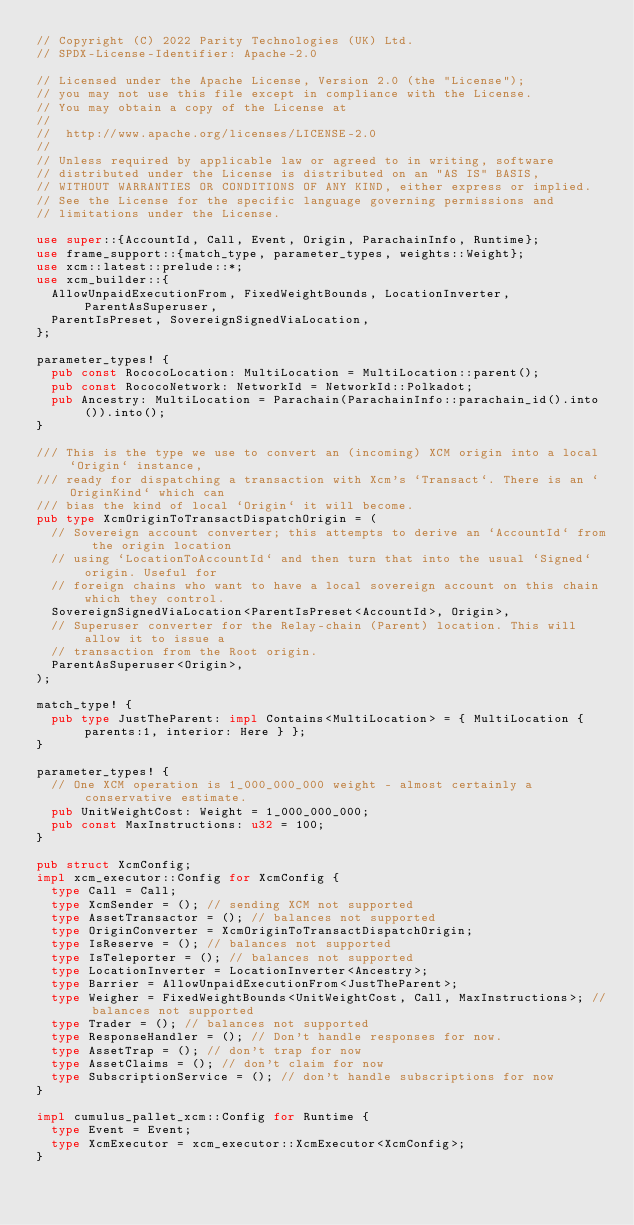<code> <loc_0><loc_0><loc_500><loc_500><_Rust_>// Copyright (C) 2022 Parity Technologies (UK) Ltd.
// SPDX-License-Identifier: Apache-2.0

// Licensed under the Apache License, Version 2.0 (the "License");
// you may not use this file except in compliance with the License.
// You may obtain a copy of the License at
//
// 	http://www.apache.org/licenses/LICENSE-2.0
//
// Unless required by applicable law or agreed to in writing, software
// distributed under the License is distributed on an "AS IS" BASIS,
// WITHOUT WARRANTIES OR CONDITIONS OF ANY KIND, either express or implied.
// See the License for the specific language governing permissions and
// limitations under the License.

use super::{AccountId, Call, Event, Origin, ParachainInfo, Runtime};
use frame_support::{match_type, parameter_types, weights::Weight};
use xcm::latest::prelude::*;
use xcm_builder::{
	AllowUnpaidExecutionFrom, FixedWeightBounds, LocationInverter, ParentAsSuperuser,
	ParentIsPreset, SovereignSignedViaLocation,
};

parameter_types! {
	pub const RococoLocation: MultiLocation = MultiLocation::parent();
	pub const RococoNetwork: NetworkId = NetworkId::Polkadot;
	pub Ancestry: MultiLocation = Parachain(ParachainInfo::parachain_id().into()).into();
}

/// This is the type we use to convert an (incoming) XCM origin into a local `Origin` instance,
/// ready for dispatching a transaction with Xcm's `Transact`. There is an `OriginKind` which can
/// bias the kind of local `Origin` it will become.
pub type XcmOriginToTransactDispatchOrigin = (
	// Sovereign account converter; this attempts to derive an `AccountId` from the origin location
	// using `LocationToAccountId` and then turn that into the usual `Signed` origin. Useful for
	// foreign chains who want to have a local sovereign account on this chain which they control.
	SovereignSignedViaLocation<ParentIsPreset<AccountId>, Origin>,
	// Superuser converter for the Relay-chain (Parent) location. This will allow it to issue a
	// transaction from the Root origin.
	ParentAsSuperuser<Origin>,
);

match_type! {
	pub type JustTheParent: impl Contains<MultiLocation> = { MultiLocation { parents:1, interior: Here } };
}

parameter_types! {
	// One XCM operation is 1_000_000_000 weight - almost certainly a conservative estimate.
	pub UnitWeightCost: Weight = 1_000_000_000;
	pub const MaxInstructions: u32 = 100;
}

pub struct XcmConfig;
impl xcm_executor::Config for XcmConfig {
	type Call = Call;
	type XcmSender = (); // sending XCM not supported
	type AssetTransactor = (); // balances not supported
	type OriginConverter = XcmOriginToTransactDispatchOrigin;
	type IsReserve = (); // balances not supported
	type IsTeleporter = (); // balances not supported
	type LocationInverter = LocationInverter<Ancestry>;
	type Barrier = AllowUnpaidExecutionFrom<JustTheParent>;
	type Weigher = FixedWeightBounds<UnitWeightCost, Call, MaxInstructions>; // balances not supported
	type Trader = (); // balances not supported
	type ResponseHandler = (); // Don't handle responses for now.
	type AssetTrap = (); // don't trap for now
	type AssetClaims = (); // don't claim for now
	type SubscriptionService = (); // don't handle subscriptions for now
}

impl cumulus_pallet_xcm::Config for Runtime {
	type Event = Event;
	type XcmExecutor = xcm_executor::XcmExecutor<XcmConfig>;
}
</code> 